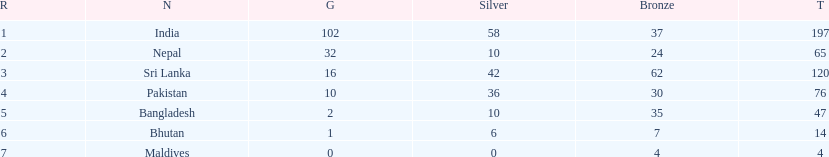What was the only nation to win less than 10 medals total? Maldives. 